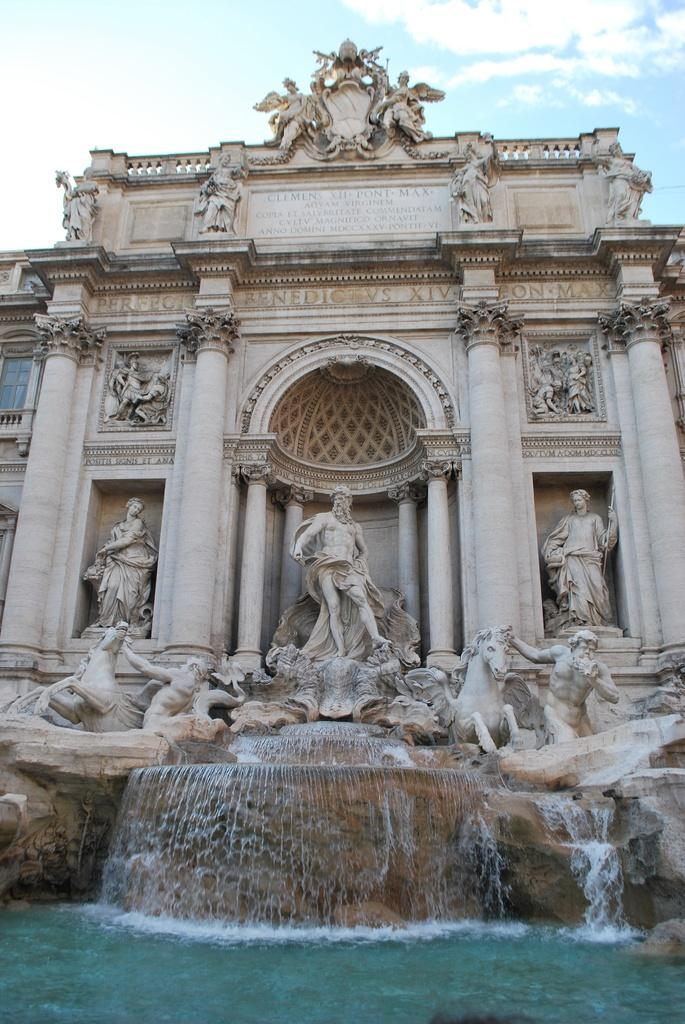What is located in the foreground of the image? There is a building and a waterfall in the foreground of the image. What can be seen at the top of the image? The sky is visible at the top of the image. What is present in the sky? Clouds are present in the sky. What sound can be heard coming from the stone in the image? There is no stone present in the image, and therefore no sound can be heard from it. 